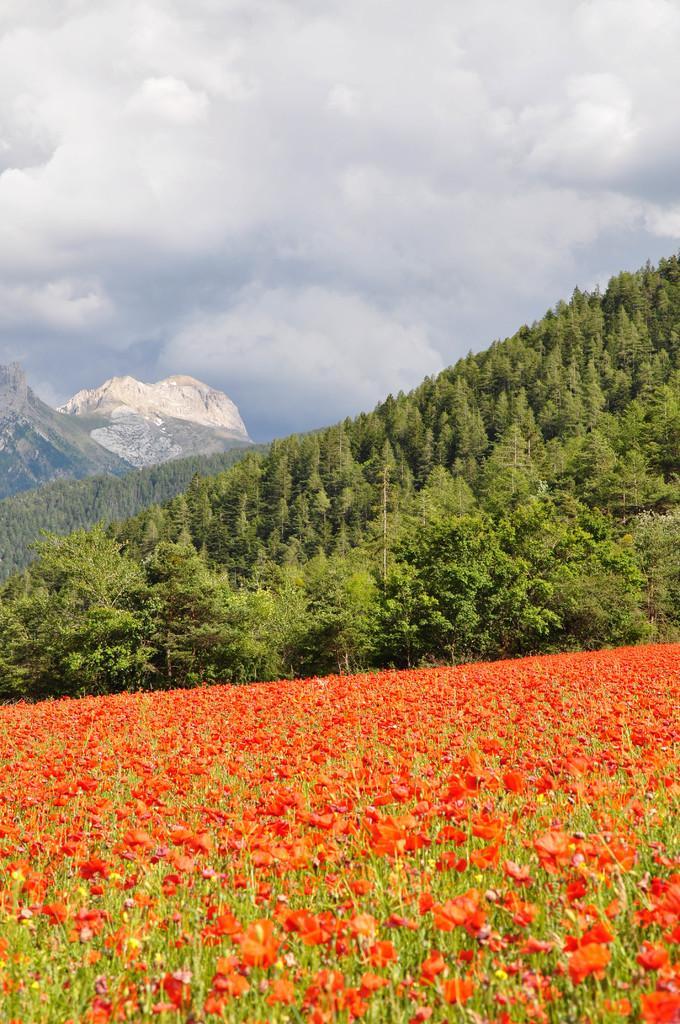How would you summarize this image in a sentence or two? This picture is clicked outside. In the foreground we can see the flowers and plants. In the background we can see the sky which is full of clouds and we can see the hills, trees and some other objects. 